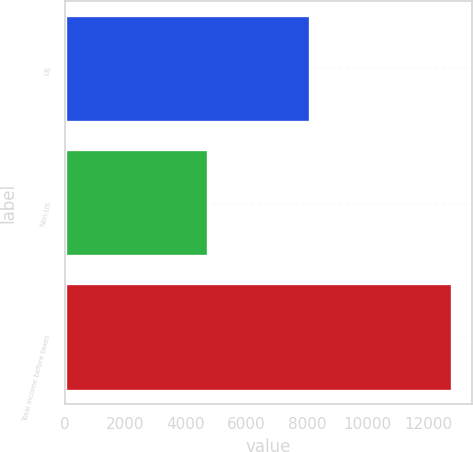Convert chart to OTSL. <chart><loc_0><loc_0><loc_500><loc_500><bar_chart><fcel>US<fcel>Non-US<fcel>Total income before taxes<nl><fcel>8088<fcel>4718<fcel>12806<nl></chart> 